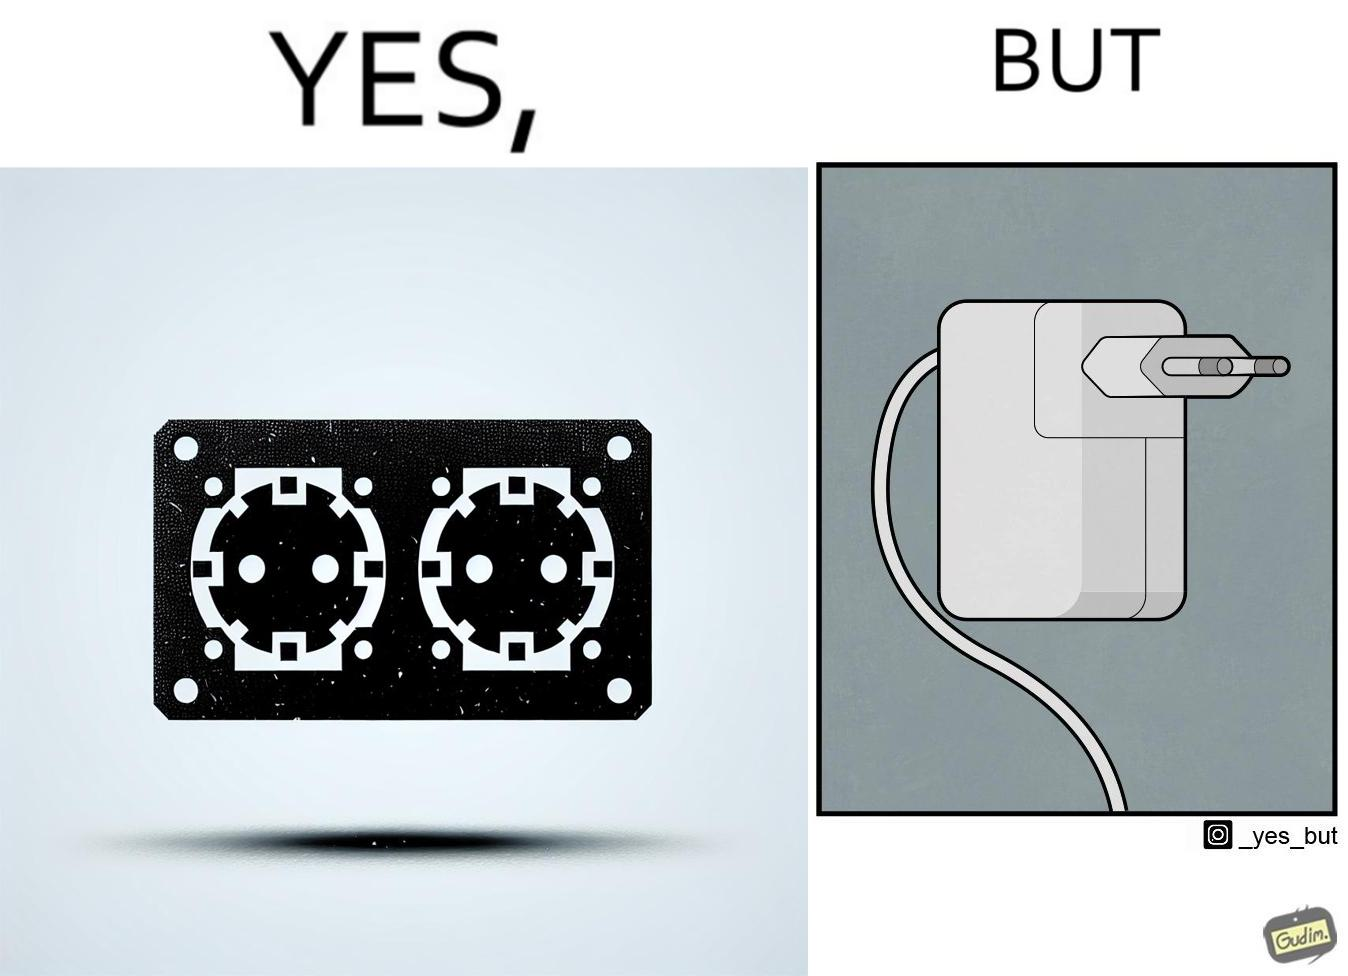Compare the left and right sides of this image. In the left part of the image: two electrical sockets side by side In the right part of the image: an electrical adapter 